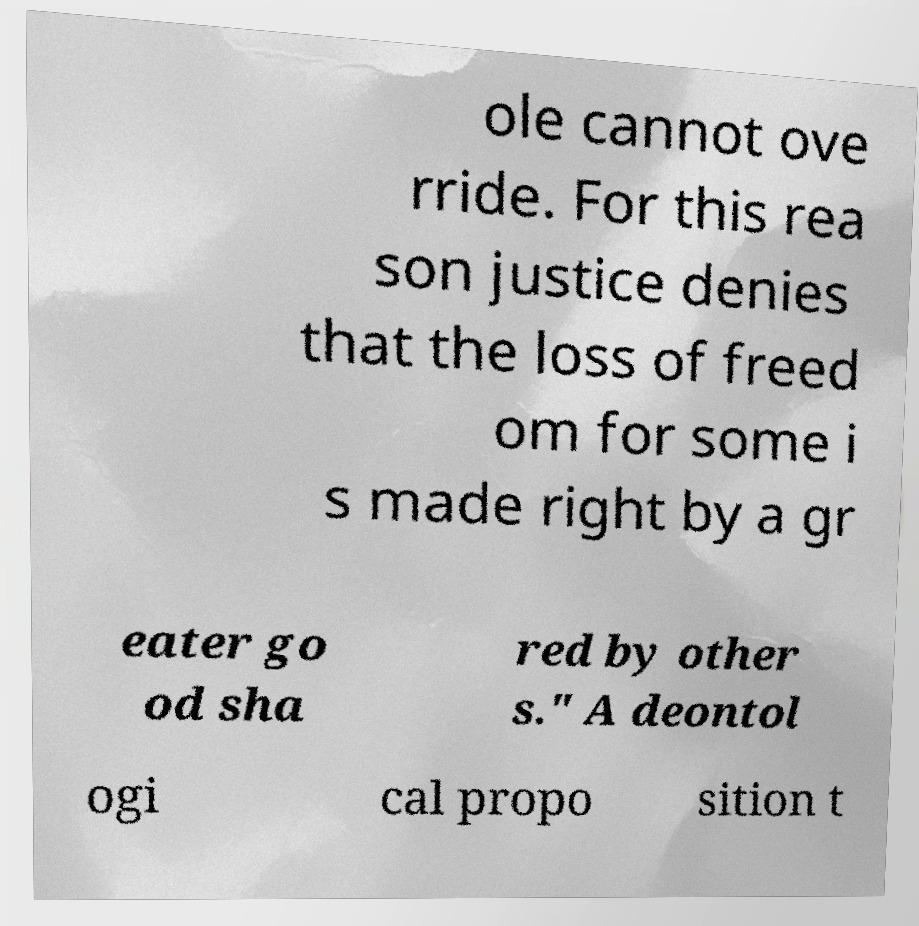There's text embedded in this image that I need extracted. Can you transcribe it verbatim? ole cannot ove rride. For this rea son justice denies that the loss of freed om for some i s made right by a gr eater go od sha red by other s." A deontol ogi cal propo sition t 